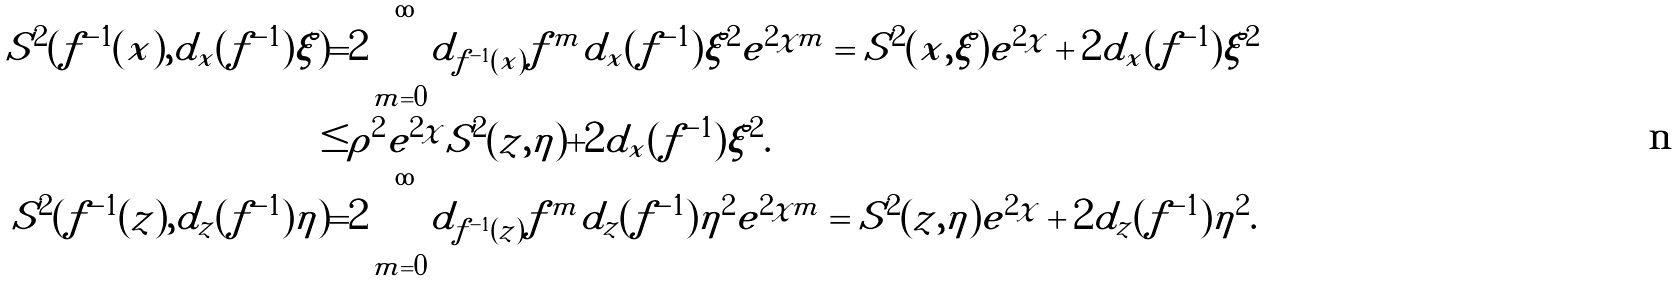Convert formula to latex. <formula><loc_0><loc_0><loc_500><loc_500>S ^ { 2 } ( f ^ { - 1 } ( x ) , d _ { x } ( f ^ { - 1 } ) \xi ) = & 2 \sum _ { m = 0 } ^ { \infty } | d _ { f ^ { - 1 } ( x ) } f ^ { m } d _ { x } ( f ^ { - 1 } ) \xi | ^ { 2 } e ^ { 2 \chi m } = S ^ { 2 } ( x , \xi ) e ^ { 2 \chi } + 2 | d _ { x } ( f ^ { - 1 } ) \xi | ^ { 2 } \\ \leq & \rho ^ { 2 } e ^ { 2 \chi } S ^ { 2 } ( z , \eta ) + 2 | d _ { x } ( f ^ { - 1 } ) \xi | ^ { 2 } . \\ S ^ { 2 } ( f ^ { - 1 } ( z ) , d _ { z } ( f ^ { - 1 } ) \eta ) = & 2 \sum _ { m = 0 } ^ { \infty } | d _ { f ^ { - 1 } ( z ) } f ^ { m } d _ { z } ( f ^ { - 1 } ) \eta | ^ { 2 } e ^ { 2 \chi m } = S ^ { 2 } ( z , \eta ) e ^ { 2 \chi } + 2 | d _ { z } ( f ^ { - 1 } ) \eta | ^ { 2 } .</formula> 